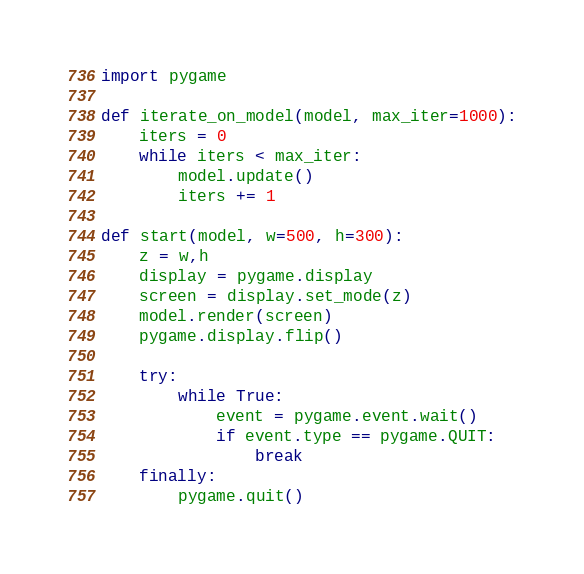Convert code to text. <code><loc_0><loc_0><loc_500><loc_500><_Python_>import pygame

def iterate_on_model(model, max_iter=1000):
    iters = 0
    while iters < max_iter:
        model.update()
        iters += 1

def start(model, w=500, h=300):
    z = w,h
    display = pygame.display
    screen = display.set_mode(z)
    model.render(screen)
    pygame.display.flip()
    
    try:
        while True:
            event = pygame.event.wait()
            if event.type == pygame.QUIT:
                break
    finally:
        pygame.quit()
</code> 